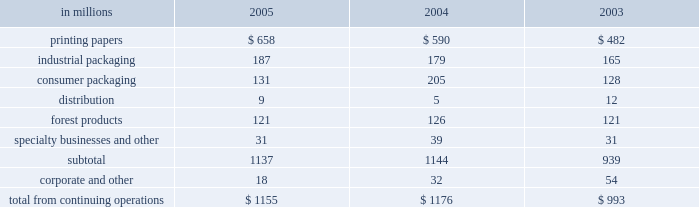Management believes it is important for interna- tional paper to maintain an investment-grade credit rat- ing to facilitate access to capital markets on favorable terms .
At december 31 , 2005 , the company held long- term credit ratings of bbb ( negative outlook ) and baa3 ( stable outlook ) from standard & poor 2019s and moody 2019s investor services , respectively .
Cash provided by operations cash provided by continuing operations totaled $ 1.5 billion for 2005 , compared with $ 2.1 billion in 2004 and $ 1.5 billion in 2003 .
The major components of cash provided by continuing operations are earnings from continuing operations adjusted for non-cash in- come and expense items and changes in working capital .
Earnings from continuing operations adjusted for non-cash items declined by $ 83 million in 2005 versus 2004 .
This compared with an increase of $ 612 million for 2004 over 2003 .
Working capital , representing international paper 2019s investments in accounts receivable and inventory less accounts payable and accrued liabilities , was $ 2.6 billion at december 31 , 2005 .
Cash used for working capital components increased by $ 591 million in 2005 , com- pared with a $ 86 million increase in 2004 and an $ 11 million increase in 2003 .
The increase in 2005 was principally due to a decline in accrued liabilities at de- cember 31 , 2005 .
Investment activities capital spending from continuing operations was $ 1.2 billion in 2005 , or 84% ( 84 % ) of depreciation and amor- tization , comparable to the $ 1.2 billion , or 87% ( 87 % ) of depreciation and amortization in 2004 , and $ 1.0 billion , or 74% ( 74 % ) of depreciation and amortization in 2003 .
The table presents capital spending from continuing operations by each of our business segments for the years ended december 31 , 2005 , 2004 and 2003 .
In millions 2005 2004 2003 .
We expect capital expenditures in 2006 to be about $ 1.2 billion , or about 80% ( 80 % ) of depreciation and amor- tization .
We will continue to focus our future capital spending on improving our key platform businesses in north america and on investments in geographic areas with strong growth opportunities .
Acquisitions in october 2005 , international paper acquired ap- proximately 65% ( 65 % ) of compagnie marocaine des cartons et des papiers ( cmcp ) , a leading moroccan corrugated packaging company , for approximately $ 80 million in cash plus assumed debt of approximately $ 40 million .
In august 2005 , pursuant to an existing agreement , international paper purchased a 50% ( 50 % ) third-party interest in ippm ( subsequently renamed international paper distribution limited ) for $ 46 million to facilitate possi- ble further growth in asian markets .
In 2001 , interna- tional paper had acquired a 25% ( 25 % ) interest in this business .
The accompanying consolidated balance sheet as of december 31 , 2005 includes preliminary estimates of the fair values of the assets and liabilities acquired , including approximately $ 50 million of goodwill .
In july 2004 , international paper acquired box usa holdings , inc .
( box usa ) for approximately $ 400 million , including the assumption of approximately $ 197 million of debt , of which approximately $ 193 mil- lion was repaid by july 31 , 2004 .
Each of the above acquisitions was accounted for using the purchase method .
The operating results of these acquisitions have been included in the con- solidated statement of operations from the dates of ac- quisition .
Financing activities 2005 : financing activities during 2005 included debt issuances of $ 1.0 billion and retirements of $ 2.7 billion , for a net debt and preferred securities reduction of $ 1.7 billion .
In november and december 2005 , international paper investments ( luxembourg ) s.ar.l. , a wholly- owned subsidiary of international paper , issued $ 700 million of long-term debt with an initial interest rate of libor plus 40 basis points that can vary depending upon the credit rating of the company , and a maturity date in november 2010 .
Additionally , the subsidiary borrowed $ 70 million under a bank credit agreement with an initial interest rate of libor plus 40 basis points that can vary depending upon the credit rating of the company , and a maturity date in november 2006 .
In december 2005 , international paper used pro- ceeds from the above borrowings , and from the sale of chh in the third quarter of 2005 , to repay approx- imately $ 190 million of notes with coupon rates ranging from 3.8% ( 3.8 % ) to 10% ( 10 % ) and original maturities from 2008 to 2029 .
The remaining proceeds from the borrowings and the chh sale will be used for further debt reductions in the first quarter of 2006. .
What percentage of capital spending from continuing operations was from the printing papers segment in 2004? 
Computations: (590 / 1176)
Answer: 0.5017. Management believes it is important for interna- tional paper to maintain an investment-grade credit rat- ing to facilitate access to capital markets on favorable terms .
At december 31 , 2005 , the company held long- term credit ratings of bbb ( negative outlook ) and baa3 ( stable outlook ) from standard & poor 2019s and moody 2019s investor services , respectively .
Cash provided by operations cash provided by continuing operations totaled $ 1.5 billion for 2005 , compared with $ 2.1 billion in 2004 and $ 1.5 billion in 2003 .
The major components of cash provided by continuing operations are earnings from continuing operations adjusted for non-cash in- come and expense items and changes in working capital .
Earnings from continuing operations adjusted for non-cash items declined by $ 83 million in 2005 versus 2004 .
This compared with an increase of $ 612 million for 2004 over 2003 .
Working capital , representing international paper 2019s investments in accounts receivable and inventory less accounts payable and accrued liabilities , was $ 2.6 billion at december 31 , 2005 .
Cash used for working capital components increased by $ 591 million in 2005 , com- pared with a $ 86 million increase in 2004 and an $ 11 million increase in 2003 .
The increase in 2005 was principally due to a decline in accrued liabilities at de- cember 31 , 2005 .
Investment activities capital spending from continuing operations was $ 1.2 billion in 2005 , or 84% ( 84 % ) of depreciation and amor- tization , comparable to the $ 1.2 billion , or 87% ( 87 % ) of depreciation and amortization in 2004 , and $ 1.0 billion , or 74% ( 74 % ) of depreciation and amortization in 2003 .
The table presents capital spending from continuing operations by each of our business segments for the years ended december 31 , 2005 , 2004 and 2003 .
In millions 2005 2004 2003 .
We expect capital expenditures in 2006 to be about $ 1.2 billion , or about 80% ( 80 % ) of depreciation and amor- tization .
We will continue to focus our future capital spending on improving our key platform businesses in north america and on investments in geographic areas with strong growth opportunities .
Acquisitions in october 2005 , international paper acquired ap- proximately 65% ( 65 % ) of compagnie marocaine des cartons et des papiers ( cmcp ) , a leading moroccan corrugated packaging company , for approximately $ 80 million in cash plus assumed debt of approximately $ 40 million .
In august 2005 , pursuant to an existing agreement , international paper purchased a 50% ( 50 % ) third-party interest in ippm ( subsequently renamed international paper distribution limited ) for $ 46 million to facilitate possi- ble further growth in asian markets .
In 2001 , interna- tional paper had acquired a 25% ( 25 % ) interest in this business .
The accompanying consolidated balance sheet as of december 31 , 2005 includes preliminary estimates of the fair values of the assets and liabilities acquired , including approximately $ 50 million of goodwill .
In july 2004 , international paper acquired box usa holdings , inc .
( box usa ) for approximately $ 400 million , including the assumption of approximately $ 197 million of debt , of which approximately $ 193 mil- lion was repaid by july 31 , 2004 .
Each of the above acquisitions was accounted for using the purchase method .
The operating results of these acquisitions have been included in the con- solidated statement of operations from the dates of ac- quisition .
Financing activities 2005 : financing activities during 2005 included debt issuances of $ 1.0 billion and retirements of $ 2.7 billion , for a net debt and preferred securities reduction of $ 1.7 billion .
In november and december 2005 , international paper investments ( luxembourg ) s.ar.l. , a wholly- owned subsidiary of international paper , issued $ 700 million of long-term debt with an initial interest rate of libor plus 40 basis points that can vary depending upon the credit rating of the company , and a maturity date in november 2010 .
Additionally , the subsidiary borrowed $ 70 million under a bank credit agreement with an initial interest rate of libor plus 40 basis points that can vary depending upon the credit rating of the company , and a maturity date in november 2006 .
In december 2005 , international paper used pro- ceeds from the above borrowings , and from the sale of chh in the third quarter of 2005 , to repay approx- imately $ 190 million of notes with coupon rates ranging from 3.8% ( 3.8 % ) to 10% ( 10 % ) and original maturities from 2008 to 2029 .
The remaining proceeds from the borrowings and the chh sale will be used for further debt reductions in the first quarter of 2006. .
What percentage of capital spending from continuing operations was from the printing papers segment in 2005? 
Computations: (658 / 1155)
Answer: 0.5697. Management believes it is important for interna- tional paper to maintain an investment-grade credit rat- ing to facilitate access to capital markets on favorable terms .
At december 31 , 2005 , the company held long- term credit ratings of bbb ( negative outlook ) and baa3 ( stable outlook ) from standard & poor 2019s and moody 2019s investor services , respectively .
Cash provided by operations cash provided by continuing operations totaled $ 1.5 billion for 2005 , compared with $ 2.1 billion in 2004 and $ 1.5 billion in 2003 .
The major components of cash provided by continuing operations are earnings from continuing operations adjusted for non-cash in- come and expense items and changes in working capital .
Earnings from continuing operations adjusted for non-cash items declined by $ 83 million in 2005 versus 2004 .
This compared with an increase of $ 612 million for 2004 over 2003 .
Working capital , representing international paper 2019s investments in accounts receivable and inventory less accounts payable and accrued liabilities , was $ 2.6 billion at december 31 , 2005 .
Cash used for working capital components increased by $ 591 million in 2005 , com- pared with a $ 86 million increase in 2004 and an $ 11 million increase in 2003 .
The increase in 2005 was principally due to a decline in accrued liabilities at de- cember 31 , 2005 .
Investment activities capital spending from continuing operations was $ 1.2 billion in 2005 , or 84% ( 84 % ) of depreciation and amor- tization , comparable to the $ 1.2 billion , or 87% ( 87 % ) of depreciation and amortization in 2004 , and $ 1.0 billion , or 74% ( 74 % ) of depreciation and amortization in 2003 .
The table presents capital spending from continuing operations by each of our business segments for the years ended december 31 , 2005 , 2004 and 2003 .
In millions 2005 2004 2003 .
We expect capital expenditures in 2006 to be about $ 1.2 billion , or about 80% ( 80 % ) of depreciation and amor- tization .
We will continue to focus our future capital spending on improving our key platform businesses in north america and on investments in geographic areas with strong growth opportunities .
Acquisitions in october 2005 , international paper acquired ap- proximately 65% ( 65 % ) of compagnie marocaine des cartons et des papiers ( cmcp ) , a leading moroccan corrugated packaging company , for approximately $ 80 million in cash plus assumed debt of approximately $ 40 million .
In august 2005 , pursuant to an existing agreement , international paper purchased a 50% ( 50 % ) third-party interest in ippm ( subsequently renamed international paper distribution limited ) for $ 46 million to facilitate possi- ble further growth in asian markets .
In 2001 , interna- tional paper had acquired a 25% ( 25 % ) interest in this business .
The accompanying consolidated balance sheet as of december 31 , 2005 includes preliminary estimates of the fair values of the assets and liabilities acquired , including approximately $ 50 million of goodwill .
In july 2004 , international paper acquired box usa holdings , inc .
( box usa ) for approximately $ 400 million , including the assumption of approximately $ 197 million of debt , of which approximately $ 193 mil- lion was repaid by july 31 , 2004 .
Each of the above acquisitions was accounted for using the purchase method .
The operating results of these acquisitions have been included in the con- solidated statement of operations from the dates of ac- quisition .
Financing activities 2005 : financing activities during 2005 included debt issuances of $ 1.0 billion and retirements of $ 2.7 billion , for a net debt and preferred securities reduction of $ 1.7 billion .
In november and december 2005 , international paper investments ( luxembourg ) s.ar.l. , a wholly- owned subsidiary of international paper , issued $ 700 million of long-term debt with an initial interest rate of libor plus 40 basis points that can vary depending upon the credit rating of the company , and a maturity date in november 2010 .
Additionally , the subsidiary borrowed $ 70 million under a bank credit agreement with an initial interest rate of libor plus 40 basis points that can vary depending upon the credit rating of the company , and a maturity date in november 2006 .
In december 2005 , international paper used pro- ceeds from the above borrowings , and from the sale of chh in the third quarter of 2005 , to repay approx- imately $ 190 million of notes with coupon rates ranging from 3.8% ( 3.8 % ) to 10% ( 10 % ) and original maturities from 2008 to 2029 .
The remaining proceeds from the borrowings and the chh sale will be used for further debt reductions in the first quarter of 2006. .
What was the percent of the total capital spending from continuing operations for industrial packaging in 2005? 
Computations: (187 / 1155)
Answer: 0.1619. 